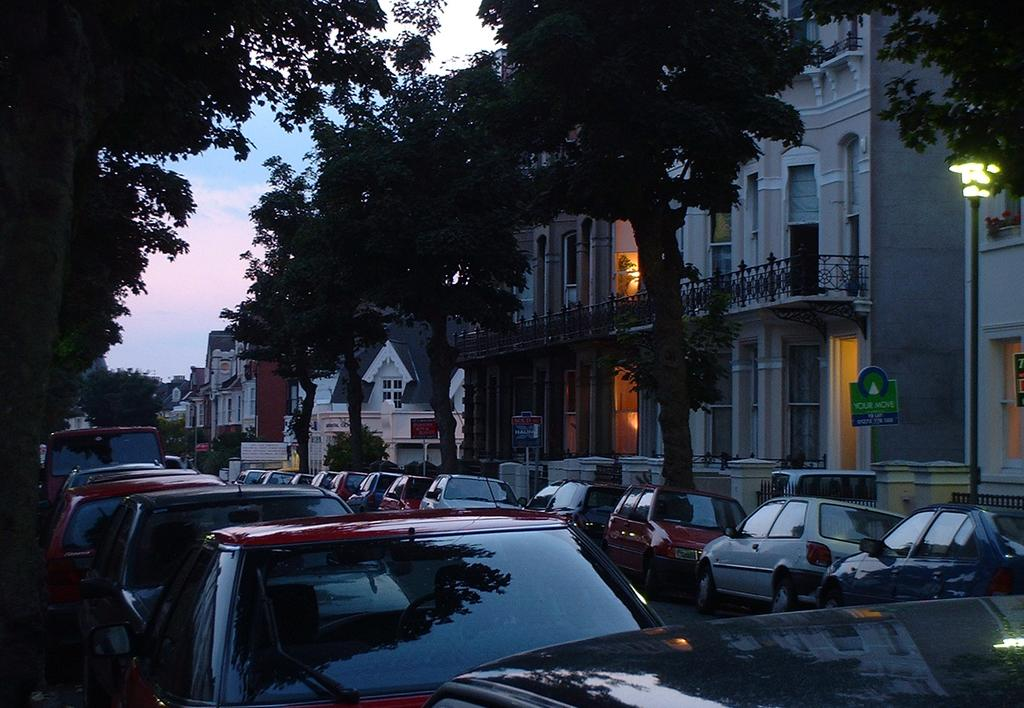What type of vehicles can be seen in the image? There are cars in the image. What natural elements are present in the image? There are trees in the image. What man-made structures are visible in the image? There are buildings in the image. What object is standing upright in the image? There is a pole in the image. What type of signage is present in the image? There is a board with text in the image. How would you describe the weather in the image? The sky is cloudy in the image. Can you tell me how many wrens are perched on the pole in the image? There are no wrens present in the image; only a pole can be seen. Is there a beggar asking for money in the image? There is no beggar present in the image. 